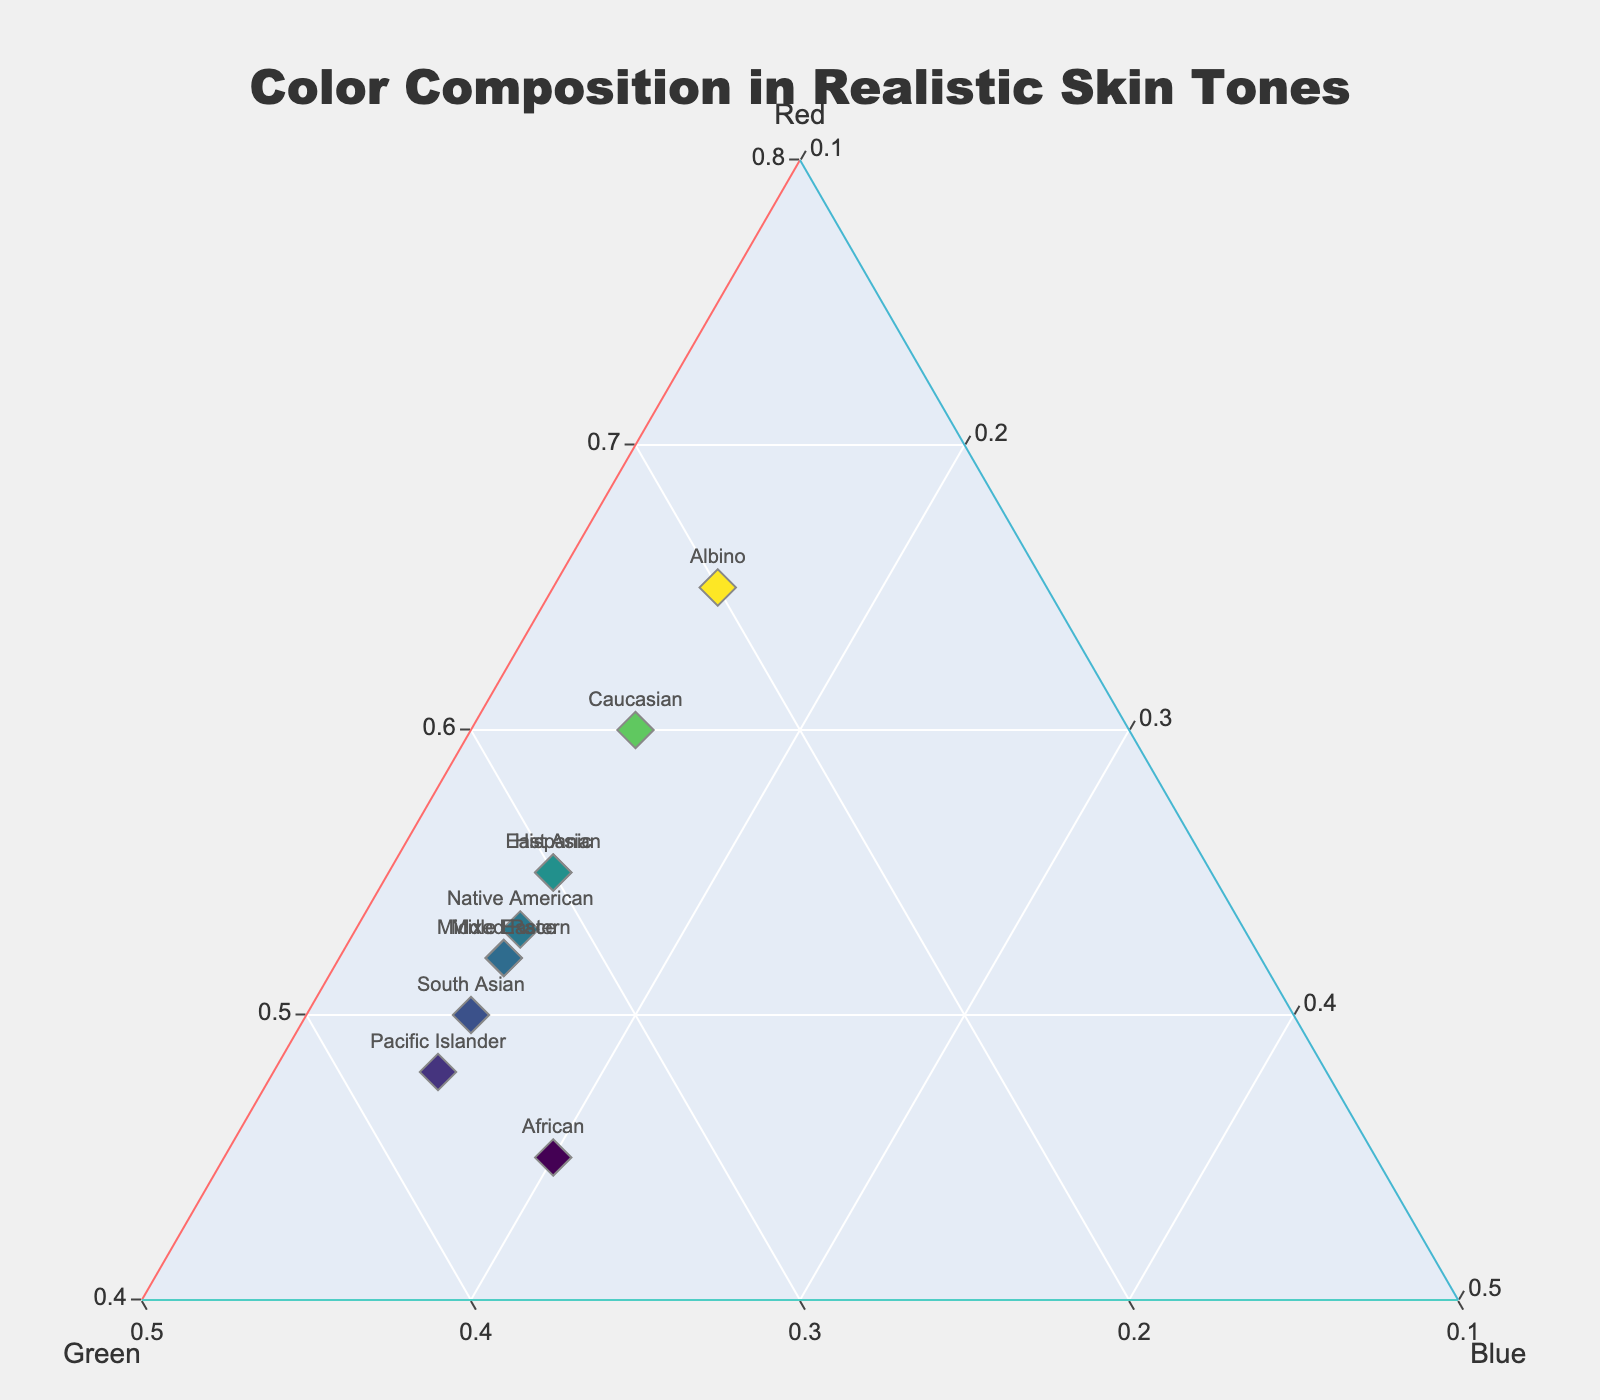What's the title of the figure? The title is prominently located at the top center of the plot.
Answer: Color Composition in Realistic Skin Tones Which ethnicity has the highest red component? By examining the plot, the data point for 'Albino' is positioned closest to the 'Red' label on the ternary axis.
Answer: Albino How many data points are represented in the ternary plot? Counting the markers labeled with ethnicities in the plot, there are ten distinct data points.
Answer: 10 Which two ethnicities have the same blue component? Observing the plot, the data points for 'East Asian', 'South Asian', 'Middle Eastern', 'Native American', 'Hispanic', 'Pacific Islander', and 'Mixed Race' all share the same blue component ratio.
Answer: East Asian, South Asian, Middle Eastern, Native American, Hispanic, Pacific Islander, Mixed Race What is the average green component for African and Pacific Islander? The green components for 'African' and 'Pacific Islander' are 0.35 and 0.37 respectively. Averaging these: (0.35 + 0.37) / 2 = 0.36.
Answer: 0.36 Which ethnicity has the most balanced red, green, and blue components? By visually assessing the proximity of points to the center of the ternary plot, 'Pacific Islander' appears to have the most balanced composition.
Answer: Pacific Islander How does the skin tone composition of East Asians compare to Caucasians in terms of red and green components? East Asians have a red component of 0.55 and green of 0.30, while Caucasians have 0.60 red and 0.25 green. The red component is higher in Caucasians while the green component is higher in East Asians.
Answer: Caucasians have more red, East Asians have more green Which ethnicity is closest to 'Mixed Race' in terms of color composition? On the ternary plot, 'Middle Eastern' is positioned very close to 'Mixed Race', indicating similar red, green, and blue ratios.
Answer: Middle Eastern 